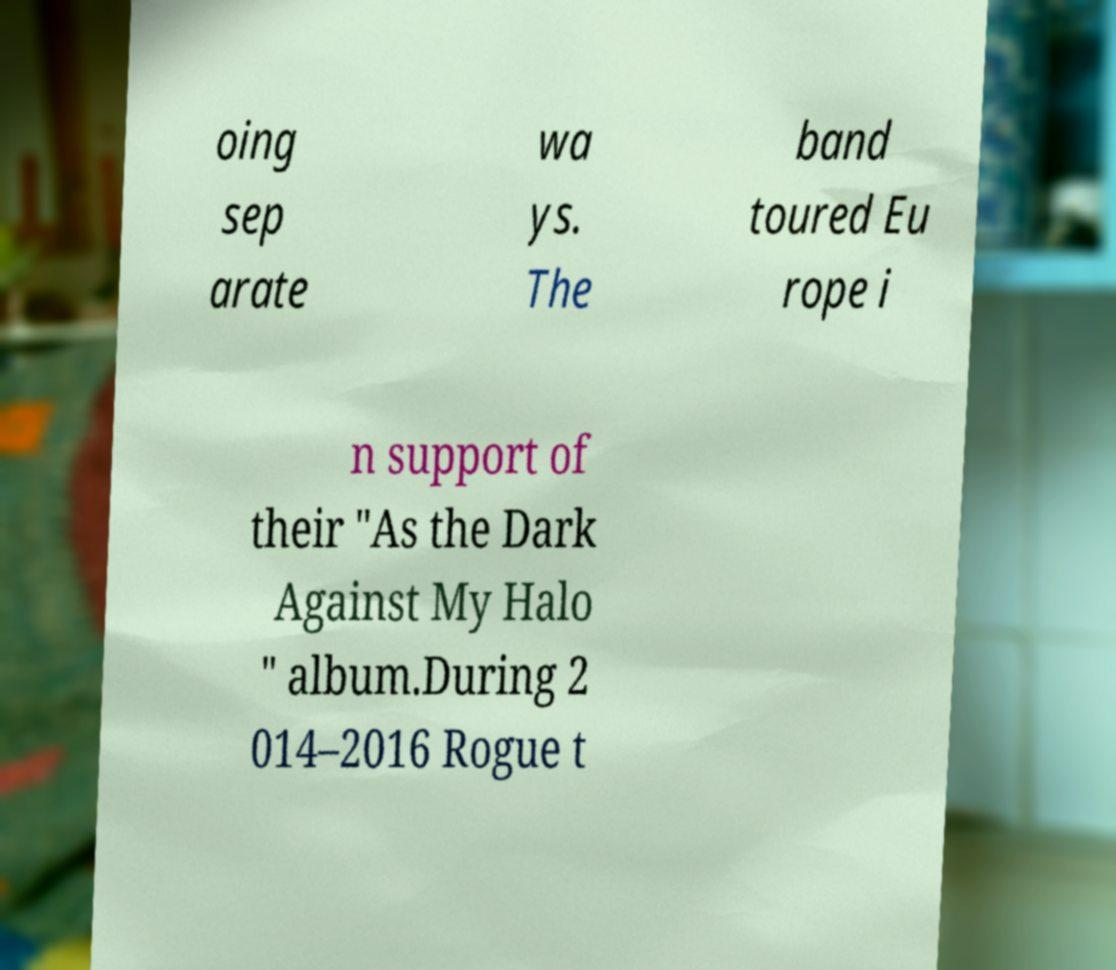Can you accurately transcribe the text from the provided image for me? oing sep arate wa ys. The band toured Eu rope i n support of their "As the Dark Against My Halo " album.During 2 014–2016 Rogue t 